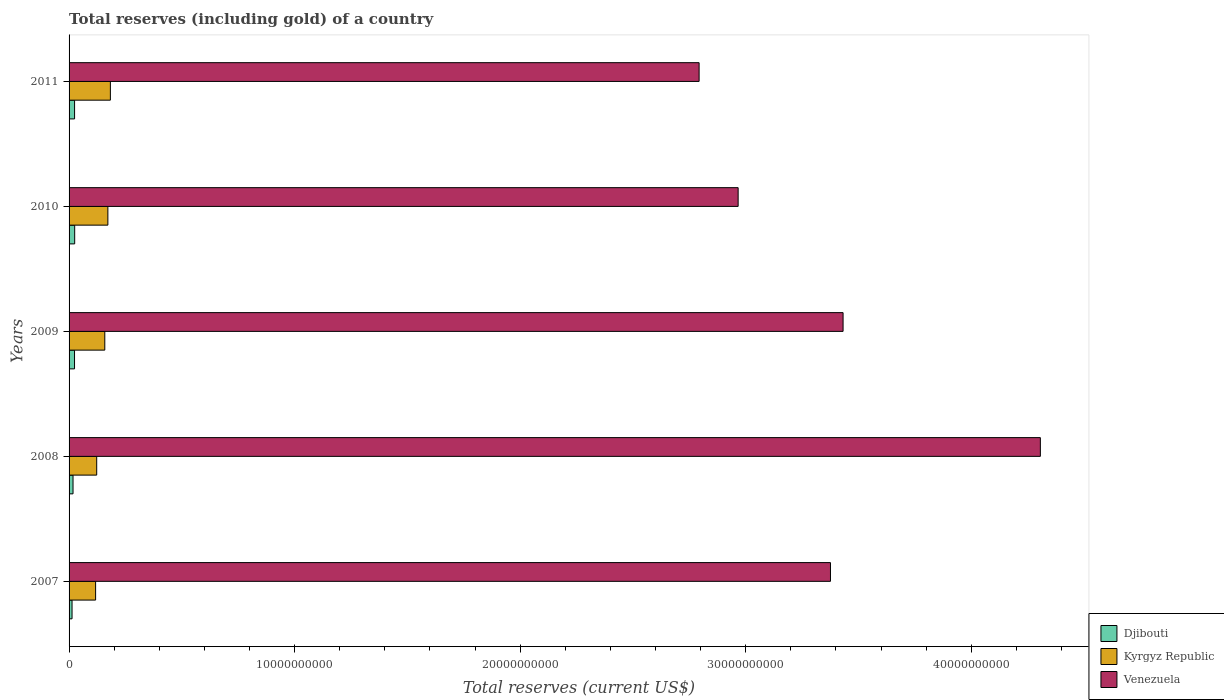How many groups of bars are there?
Ensure brevity in your answer.  5. Are the number of bars per tick equal to the number of legend labels?
Your answer should be very brief. Yes. Are the number of bars on each tick of the Y-axis equal?
Your response must be concise. Yes. What is the total reserves (including gold) in Djibouti in 2008?
Give a very brief answer. 1.75e+08. Across all years, what is the maximum total reserves (including gold) in Djibouti?
Make the answer very short. 2.49e+08. Across all years, what is the minimum total reserves (including gold) in Kyrgyz Republic?
Ensure brevity in your answer.  1.18e+09. In which year was the total reserves (including gold) in Venezuela minimum?
Provide a succinct answer. 2011. What is the total total reserves (including gold) in Djibouti in the graph?
Provide a succinct answer. 1.04e+09. What is the difference between the total reserves (including gold) in Venezuela in 2008 and that in 2009?
Offer a very short reply. 8.75e+09. What is the difference between the total reserves (including gold) in Venezuela in 2011 and the total reserves (including gold) in Djibouti in 2007?
Offer a very short reply. 2.78e+1. What is the average total reserves (including gold) in Djibouti per year?
Provide a succinct answer. 2.09e+08. In the year 2011, what is the difference between the total reserves (including gold) in Djibouti and total reserves (including gold) in Venezuela?
Your answer should be very brief. -2.77e+1. What is the ratio of the total reserves (including gold) in Djibouti in 2009 to that in 2011?
Offer a terse response. 0.99. Is the total reserves (including gold) in Venezuela in 2007 less than that in 2010?
Offer a terse response. No. What is the difference between the highest and the second highest total reserves (including gold) in Djibouti?
Your response must be concise. 4.89e+06. What is the difference between the highest and the lowest total reserves (including gold) in Kyrgyz Republic?
Provide a short and direct response. 6.55e+08. In how many years, is the total reserves (including gold) in Djibouti greater than the average total reserves (including gold) in Djibouti taken over all years?
Ensure brevity in your answer.  3. What does the 2nd bar from the top in 2011 represents?
Offer a very short reply. Kyrgyz Republic. What does the 3rd bar from the bottom in 2010 represents?
Provide a short and direct response. Venezuela. How many years are there in the graph?
Your answer should be compact. 5. Are the values on the major ticks of X-axis written in scientific E-notation?
Your answer should be compact. No. Does the graph contain any zero values?
Provide a succinct answer. No. Does the graph contain grids?
Your answer should be very brief. No. How many legend labels are there?
Keep it short and to the point. 3. What is the title of the graph?
Ensure brevity in your answer.  Total reserves (including gold) of a country. Does "OECD members" appear as one of the legend labels in the graph?
Give a very brief answer. No. What is the label or title of the X-axis?
Your answer should be very brief. Total reserves (current US$). What is the Total reserves (current US$) in Djibouti in 2007?
Your answer should be compact. 1.32e+08. What is the Total reserves (current US$) in Kyrgyz Republic in 2007?
Provide a succinct answer. 1.18e+09. What is the Total reserves (current US$) of Venezuela in 2007?
Your response must be concise. 3.38e+1. What is the Total reserves (current US$) in Djibouti in 2008?
Ensure brevity in your answer.  1.75e+08. What is the Total reserves (current US$) in Kyrgyz Republic in 2008?
Make the answer very short. 1.23e+09. What is the Total reserves (current US$) in Venezuela in 2008?
Offer a terse response. 4.31e+1. What is the Total reserves (current US$) of Djibouti in 2009?
Your answer should be very brief. 2.42e+08. What is the Total reserves (current US$) in Kyrgyz Republic in 2009?
Ensure brevity in your answer.  1.58e+09. What is the Total reserves (current US$) in Venezuela in 2009?
Make the answer very short. 3.43e+1. What is the Total reserves (current US$) in Djibouti in 2010?
Provide a short and direct response. 2.49e+08. What is the Total reserves (current US$) of Kyrgyz Republic in 2010?
Your response must be concise. 1.72e+09. What is the Total reserves (current US$) of Venezuela in 2010?
Offer a very short reply. 2.97e+1. What is the Total reserves (current US$) of Djibouti in 2011?
Offer a very short reply. 2.44e+08. What is the Total reserves (current US$) in Kyrgyz Republic in 2011?
Keep it short and to the point. 1.83e+09. What is the Total reserves (current US$) in Venezuela in 2011?
Offer a very short reply. 2.79e+1. Across all years, what is the maximum Total reserves (current US$) in Djibouti?
Offer a very short reply. 2.49e+08. Across all years, what is the maximum Total reserves (current US$) of Kyrgyz Republic?
Offer a very short reply. 1.83e+09. Across all years, what is the maximum Total reserves (current US$) in Venezuela?
Your response must be concise. 4.31e+1. Across all years, what is the minimum Total reserves (current US$) of Djibouti?
Provide a succinct answer. 1.32e+08. Across all years, what is the minimum Total reserves (current US$) of Kyrgyz Republic?
Keep it short and to the point. 1.18e+09. Across all years, what is the minimum Total reserves (current US$) in Venezuela?
Your answer should be compact. 2.79e+1. What is the total Total reserves (current US$) in Djibouti in the graph?
Ensure brevity in your answer.  1.04e+09. What is the total Total reserves (current US$) in Kyrgyz Republic in the graph?
Offer a very short reply. 7.54e+09. What is the total Total reserves (current US$) of Venezuela in the graph?
Your answer should be compact. 1.69e+11. What is the difference between the Total reserves (current US$) in Djibouti in 2007 and that in 2008?
Your answer should be compact. -4.34e+07. What is the difference between the Total reserves (current US$) in Kyrgyz Republic in 2007 and that in 2008?
Provide a short and direct response. -4.86e+07. What is the difference between the Total reserves (current US$) of Venezuela in 2007 and that in 2008?
Provide a short and direct response. -9.31e+09. What is the difference between the Total reserves (current US$) in Djibouti in 2007 and that in 2009?
Provide a short and direct response. -1.10e+08. What is the difference between the Total reserves (current US$) in Kyrgyz Republic in 2007 and that in 2009?
Keep it short and to the point. -4.08e+08. What is the difference between the Total reserves (current US$) of Venezuela in 2007 and that in 2009?
Your answer should be compact. -5.59e+08. What is the difference between the Total reserves (current US$) in Djibouti in 2007 and that in 2010?
Your response must be concise. -1.17e+08. What is the difference between the Total reserves (current US$) in Kyrgyz Republic in 2007 and that in 2010?
Make the answer very short. -5.44e+08. What is the difference between the Total reserves (current US$) in Venezuela in 2007 and that in 2010?
Make the answer very short. 4.09e+09. What is the difference between the Total reserves (current US$) of Djibouti in 2007 and that in 2011?
Make the answer very short. -1.12e+08. What is the difference between the Total reserves (current US$) in Kyrgyz Republic in 2007 and that in 2011?
Ensure brevity in your answer.  -6.55e+08. What is the difference between the Total reserves (current US$) in Venezuela in 2007 and that in 2011?
Your response must be concise. 5.82e+09. What is the difference between the Total reserves (current US$) of Djibouti in 2008 and that in 2009?
Ensure brevity in your answer.  -6.63e+07. What is the difference between the Total reserves (current US$) in Kyrgyz Republic in 2008 and that in 2009?
Provide a succinct answer. -3.59e+08. What is the difference between the Total reserves (current US$) of Venezuela in 2008 and that in 2009?
Offer a very short reply. 8.75e+09. What is the difference between the Total reserves (current US$) of Djibouti in 2008 and that in 2010?
Offer a terse response. -7.35e+07. What is the difference between the Total reserves (current US$) of Kyrgyz Republic in 2008 and that in 2010?
Your response must be concise. -4.95e+08. What is the difference between the Total reserves (current US$) of Venezuela in 2008 and that in 2010?
Your response must be concise. 1.34e+1. What is the difference between the Total reserves (current US$) of Djibouti in 2008 and that in 2011?
Provide a short and direct response. -6.86e+07. What is the difference between the Total reserves (current US$) in Kyrgyz Republic in 2008 and that in 2011?
Ensure brevity in your answer.  -6.06e+08. What is the difference between the Total reserves (current US$) of Venezuela in 2008 and that in 2011?
Provide a short and direct response. 1.51e+1. What is the difference between the Total reserves (current US$) of Djibouti in 2009 and that in 2010?
Your answer should be compact. -7.17e+06. What is the difference between the Total reserves (current US$) of Kyrgyz Republic in 2009 and that in 2010?
Offer a terse response. -1.36e+08. What is the difference between the Total reserves (current US$) of Venezuela in 2009 and that in 2010?
Your response must be concise. 4.65e+09. What is the difference between the Total reserves (current US$) of Djibouti in 2009 and that in 2011?
Your answer should be compact. -2.28e+06. What is the difference between the Total reserves (current US$) in Kyrgyz Republic in 2009 and that in 2011?
Offer a very short reply. -2.47e+08. What is the difference between the Total reserves (current US$) in Venezuela in 2009 and that in 2011?
Your response must be concise. 6.38e+09. What is the difference between the Total reserves (current US$) in Djibouti in 2010 and that in 2011?
Your answer should be compact. 4.89e+06. What is the difference between the Total reserves (current US$) of Kyrgyz Republic in 2010 and that in 2011?
Your answer should be compact. -1.11e+08. What is the difference between the Total reserves (current US$) in Venezuela in 2010 and that in 2011?
Your response must be concise. 1.73e+09. What is the difference between the Total reserves (current US$) of Djibouti in 2007 and the Total reserves (current US$) of Kyrgyz Republic in 2008?
Give a very brief answer. -1.09e+09. What is the difference between the Total reserves (current US$) in Djibouti in 2007 and the Total reserves (current US$) in Venezuela in 2008?
Offer a terse response. -4.29e+1. What is the difference between the Total reserves (current US$) of Kyrgyz Republic in 2007 and the Total reserves (current US$) of Venezuela in 2008?
Your answer should be compact. -4.19e+1. What is the difference between the Total reserves (current US$) of Djibouti in 2007 and the Total reserves (current US$) of Kyrgyz Republic in 2009?
Provide a short and direct response. -1.45e+09. What is the difference between the Total reserves (current US$) in Djibouti in 2007 and the Total reserves (current US$) in Venezuela in 2009?
Your answer should be very brief. -3.42e+1. What is the difference between the Total reserves (current US$) of Kyrgyz Republic in 2007 and the Total reserves (current US$) of Venezuela in 2009?
Your answer should be very brief. -3.31e+1. What is the difference between the Total reserves (current US$) in Djibouti in 2007 and the Total reserves (current US$) in Kyrgyz Republic in 2010?
Provide a short and direct response. -1.59e+09. What is the difference between the Total reserves (current US$) of Djibouti in 2007 and the Total reserves (current US$) of Venezuela in 2010?
Your answer should be very brief. -2.95e+1. What is the difference between the Total reserves (current US$) in Kyrgyz Republic in 2007 and the Total reserves (current US$) in Venezuela in 2010?
Provide a succinct answer. -2.85e+1. What is the difference between the Total reserves (current US$) of Djibouti in 2007 and the Total reserves (current US$) of Kyrgyz Republic in 2011?
Provide a short and direct response. -1.70e+09. What is the difference between the Total reserves (current US$) of Djibouti in 2007 and the Total reserves (current US$) of Venezuela in 2011?
Provide a short and direct response. -2.78e+1. What is the difference between the Total reserves (current US$) in Kyrgyz Republic in 2007 and the Total reserves (current US$) in Venezuela in 2011?
Your response must be concise. -2.68e+1. What is the difference between the Total reserves (current US$) in Djibouti in 2008 and the Total reserves (current US$) in Kyrgyz Republic in 2009?
Make the answer very short. -1.41e+09. What is the difference between the Total reserves (current US$) in Djibouti in 2008 and the Total reserves (current US$) in Venezuela in 2009?
Your answer should be compact. -3.41e+1. What is the difference between the Total reserves (current US$) of Kyrgyz Republic in 2008 and the Total reserves (current US$) of Venezuela in 2009?
Keep it short and to the point. -3.31e+1. What is the difference between the Total reserves (current US$) of Djibouti in 2008 and the Total reserves (current US$) of Kyrgyz Republic in 2010?
Your response must be concise. -1.54e+09. What is the difference between the Total reserves (current US$) of Djibouti in 2008 and the Total reserves (current US$) of Venezuela in 2010?
Offer a terse response. -2.95e+1. What is the difference between the Total reserves (current US$) in Kyrgyz Republic in 2008 and the Total reserves (current US$) in Venezuela in 2010?
Offer a terse response. -2.84e+1. What is the difference between the Total reserves (current US$) in Djibouti in 2008 and the Total reserves (current US$) in Kyrgyz Republic in 2011?
Provide a succinct answer. -1.66e+09. What is the difference between the Total reserves (current US$) in Djibouti in 2008 and the Total reserves (current US$) in Venezuela in 2011?
Your answer should be very brief. -2.78e+1. What is the difference between the Total reserves (current US$) of Kyrgyz Republic in 2008 and the Total reserves (current US$) of Venezuela in 2011?
Keep it short and to the point. -2.67e+1. What is the difference between the Total reserves (current US$) of Djibouti in 2009 and the Total reserves (current US$) of Kyrgyz Republic in 2010?
Provide a succinct answer. -1.48e+09. What is the difference between the Total reserves (current US$) of Djibouti in 2009 and the Total reserves (current US$) of Venezuela in 2010?
Make the answer very short. -2.94e+1. What is the difference between the Total reserves (current US$) of Kyrgyz Republic in 2009 and the Total reserves (current US$) of Venezuela in 2010?
Make the answer very short. -2.81e+1. What is the difference between the Total reserves (current US$) in Djibouti in 2009 and the Total reserves (current US$) in Kyrgyz Republic in 2011?
Offer a terse response. -1.59e+09. What is the difference between the Total reserves (current US$) of Djibouti in 2009 and the Total reserves (current US$) of Venezuela in 2011?
Ensure brevity in your answer.  -2.77e+1. What is the difference between the Total reserves (current US$) in Kyrgyz Republic in 2009 and the Total reserves (current US$) in Venezuela in 2011?
Provide a short and direct response. -2.64e+1. What is the difference between the Total reserves (current US$) of Djibouti in 2010 and the Total reserves (current US$) of Kyrgyz Republic in 2011?
Provide a succinct answer. -1.58e+09. What is the difference between the Total reserves (current US$) in Djibouti in 2010 and the Total reserves (current US$) in Venezuela in 2011?
Keep it short and to the point. -2.77e+1. What is the difference between the Total reserves (current US$) of Kyrgyz Republic in 2010 and the Total reserves (current US$) of Venezuela in 2011?
Provide a short and direct response. -2.62e+1. What is the average Total reserves (current US$) of Djibouti per year?
Your answer should be very brief. 2.09e+08. What is the average Total reserves (current US$) in Kyrgyz Republic per year?
Offer a terse response. 1.51e+09. What is the average Total reserves (current US$) in Venezuela per year?
Give a very brief answer. 3.37e+1. In the year 2007, what is the difference between the Total reserves (current US$) in Djibouti and Total reserves (current US$) in Kyrgyz Republic?
Offer a terse response. -1.04e+09. In the year 2007, what is the difference between the Total reserves (current US$) of Djibouti and Total reserves (current US$) of Venezuela?
Give a very brief answer. -3.36e+1. In the year 2007, what is the difference between the Total reserves (current US$) in Kyrgyz Republic and Total reserves (current US$) in Venezuela?
Provide a short and direct response. -3.26e+1. In the year 2008, what is the difference between the Total reserves (current US$) in Djibouti and Total reserves (current US$) in Kyrgyz Republic?
Provide a succinct answer. -1.05e+09. In the year 2008, what is the difference between the Total reserves (current US$) of Djibouti and Total reserves (current US$) of Venezuela?
Ensure brevity in your answer.  -4.29e+1. In the year 2008, what is the difference between the Total reserves (current US$) of Kyrgyz Republic and Total reserves (current US$) of Venezuela?
Make the answer very short. -4.18e+1. In the year 2009, what is the difference between the Total reserves (current US$) of Djibouti and Total reserves (current US$) of Kyrgyz Republic?
Your answer should be compact. -1.34e+09. In the year 2009, what is the difference between the Total reserves (current US$) of Djibouti and Total reserves (current US$) of Venezuela?
Offer a terse response. -3.41e+1. In the year 2009, what is the difference between the Total reserves (current US$) of Kyrgyz Republic and Total reserves (current US$) of Venezuela?
Provide a succinct answer. -3.27e+1. In the year 2010, what is the difference between the Total reserves (current US$) of Djibouti and Total reserves (current US$) of Kyrgyz Republic?
Your response must be concise. -1.47e+09. In the year 2010, what is the difference between the Total reserves (current US$) in Djibouti and Total reserves (current US$) in Venezuela?
Ensure brevity in your answer.  -2.94e+1. In the year 2010, what is the difference between the Total reserves (current US$) of Kyrgyz Republic and Total reserves (current US$) of Venezuela?
Provide a short and direct response. -2.79e+1. In the year 2011, what is the difference between the Total reserves (current US$) of Djibouti and Total reserves (current US$) of Kyrgyz Republic?
Your response must be concise. -1.59e+09. In the year 2011, what is the difference between the Total reserves (current US$) in Djibouti and Total reserves (current US$) in Venezuela?
Your answer should be compact. -2.77e+1. In the year 2011, what is the difference between the Total reserves (current US$) of Kyrgyz Republic and Total reserves (current US$) of Venezuela?
Offer a terse response. -2.61e+1. What is the ratio of the Total reserves (current US$) in Djibouti in 2007 to that in 2008?
Offer a terse response. 0.75. What is the ratio of the Total reserves (current US$) in Kyrgyz Republic in 2007 to that in 2008?
Your answer should be compact. 0.96. What is the ratio of the Total reserves (current US$) of Venezuela in 2007 to that in 2008?
Your answer should be very brief. 0.78. What is the ratio of the Total reserves (current US$) of Djibouti in 2007 to that in 2009?
Your response must be concise. 0.55. What is the ratio of the Total reserves (current US$) in Kyrgyz Republic in 2007 to that in 2009?
Your response must be concise. 0.74. What is the ratio of the Total reserves (current US$) of Venezuela in 2007 to that in 2009?
Give a very brief answer. 0.98. What is the ratio of the Total reserves (current US$) in Djibouti in 2007 to that in 2010?
Make the answer very short. 0.53. What is the ratio of the Total reserves (current US$) in Kyrgyz Republic in 2007 to that in 2010?
Provide a short and direct response. 0.68. What is the ratio of the Total reserves (current US$) in Venezuela in 2007 to that in 2010?
Your answer should be compact. 1.14. What is the ratio of the Total reserves (current US$) in Djibouti in 2007 to that in 2011?
Ensure brevity in your answer.  0.54. What is the ratio of the Total reserves (current US$) in Kyrgyz Republic in 2007 to that in 2011?
Offer a terse response. 0.64. What is the ratio of the Total reserves (current US$) in Venezuela in 2007 to that in 2011?
Provide a succinct answer. 1.21. What is the ratio of the Total reserves (current US$) of Djibouti in 2008 to that in 2009?
Give a very brief answer. 0.73. What is the ratio of the Total reserves (current US$) of Kyrgyz Republic in 2008 to that in 2009?
Your answer should be compact. 0.77. What is the ratio of the Total reserves (current US$) in Venezuela in 2008 to that in 2009?
Your response must be concise. 1.25. What is the ratio of the Total reserves (current US$) in Djibouti in 2008 to that in 2010?
Give a very brief answer. 0.7. What is the ratio of the Total reserves (current US$) of Kyrgyz Republic in 2008 to that in 2010?
Your answer should be compact. 0.71. What is the ratio of the Total reserves (current US$) of Venezuela in 2008 to that in 2010?
Your answer should be compact. 1.45. What is the ratio of the Total reserves (current US$) of Djibouti in 2008 to that in 2011?
Provide a short and direct response. 0.72. What is the ratio of the Total reserves (current US$) of Kyrgyz Republic in 2008 to that in 2011?
Your answer should be very brief. 0.67. What is the ratio of the Total reserves (current US$) of Venezuela in 2008 to that in 2011?
Make the answer very short. 1.54. What is the ratio of the Total reserves (current US$) in Djibouti in 2009 to that in 2010?
Your answer should be compact. 0.97. What is the ratio of the Total reserves (current US$) of Kyrgyz Republic in 2009 to that in 2010?
Offer a terse response. 0.92. What is the ratio of the Total reserves (current US$) in Venezuela in 2009 to that in 2010?
Offer a very short reply. 1.16. What is the ratio of the Total reserves (current US$) of Djibouti in 2009 to that in 2011?
Your response must be concise. 0.99. What is the ratio of the Total reserves (current US$) of Kyrgyz Republic in 2009 to that in 2011?
Ensure brevity in your answer.  0.87. What is the ratio of the Total reserves (current US$) in Venezuela in 2009 to that in 2011?
Keep it short and to the point. 1.23. What is the ratio of the Total reserves (current US$) in Djibouti in 2010 to that in 2011?
Your response must be concise. 1.02. What is the ratio of the Total reserves (current US$) in Kyrgyz Republic in 2010 to that in 2011?
Give a very brief answer. 0.94. What is the ratio of the Total reserves (current US$) in Venezuela in 2010 to that in 2011?
Ensure brevity in your answer.  1.06. What is the difference between the highest and the second highest Total reserves (current US$) of Djibouti?
Ensure brevity in your answer.  4.89e+06. What is the difference between the highest and the second highest Total reserves (current US$) in Kyrgyz Republic?
Offer a terse response. 1.11e+08. What is the difference between the highest and the second highest Total reserves (current US$) in Venezuela?
Provide a succinct answer. 8.75e+09. What is the difference between the highest and the lowest Total reserves (current US$) of Djibouti?
Provide a short and direct response. 1.17e+08. What is the difference between the highest and the lowest Total reserves (current US$) in Kyrgyz Republic?
Provide a succinct answer. 6.55e+08. What is the difference between the highest and the lowest Total reserves (current US$) in Venezuela?
Ensure brevity in your answer.  1.51e+1. 